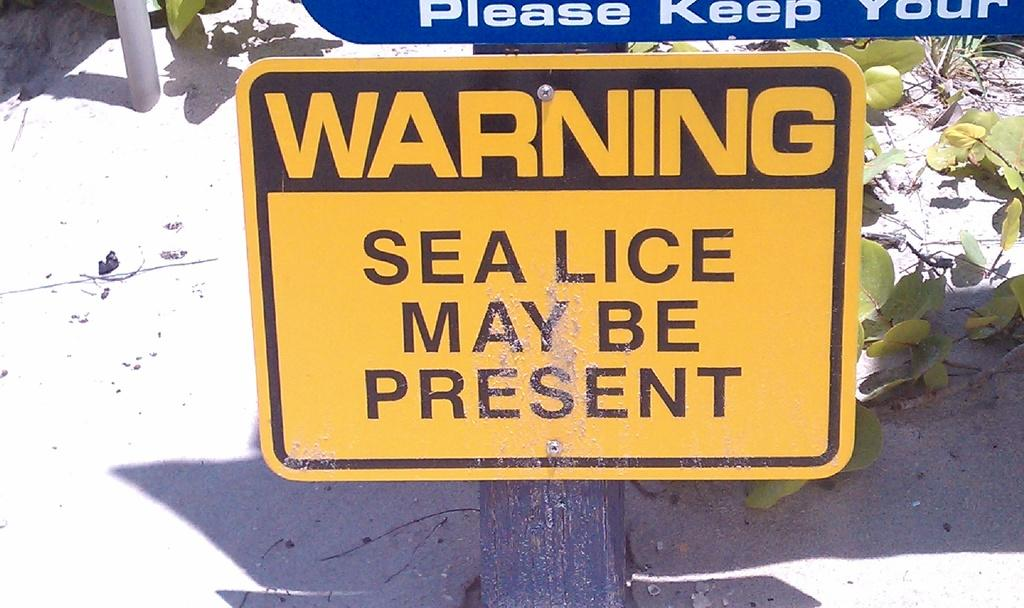What is on the pole in the image? There is a warning board on a pole in the image. Can you describe another board in the image? Yes, there is another board in the image. What type of vegetation can be seen on the ground in the image? There is a plant on the ground in the image. What type of wine is being served at the dinner in the image? There is no dinner or wine present in the image; it only features a warning board, another board, and a plant. 